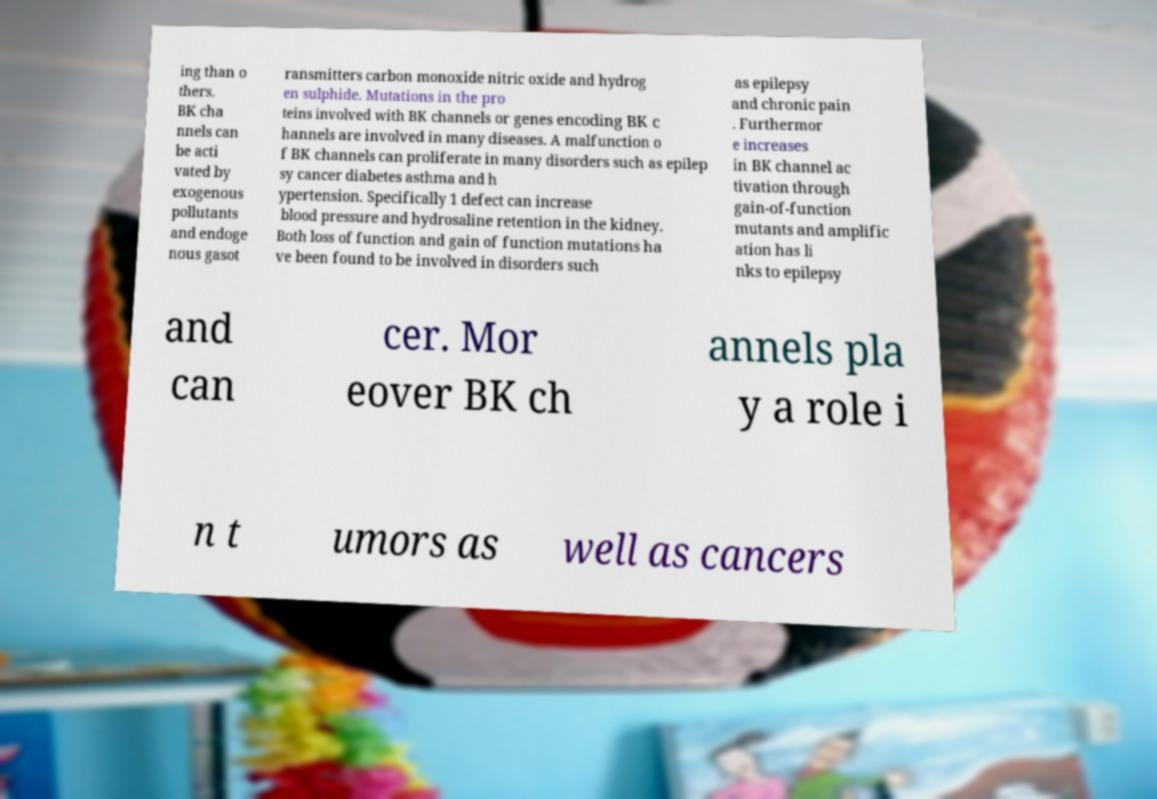Could you assist in decoding the text presented in this image and type it out clearly? ing than o thers. BK cha nnels can be acti vated by exogenous pollutants and endoge nous gasot ransmitters carbon monoxide nitric oxide and hydrog en sulphide. Mutations in the pro teins involved with BK channels or genes encoding BK c hannels are involved in many diseases. A malfunction o f BK channels can proliferate in many disorders such as epilep sy cancer diabetes asthma and h ypertension. Specifically 1 defect can increase blood pressure and hydrosaline retention in the kidney. Both loss of function and gain of function mutations ha ve been found to be involved in disorders such as epilepsy and chronic pain . Furthermor e increases in BK channel ac tivation through gain-of-function mutants and amplific ation has li nks to epilepsy and can cer. Mor eover BK ch annels pla y a role i n t umors as well as cancers 